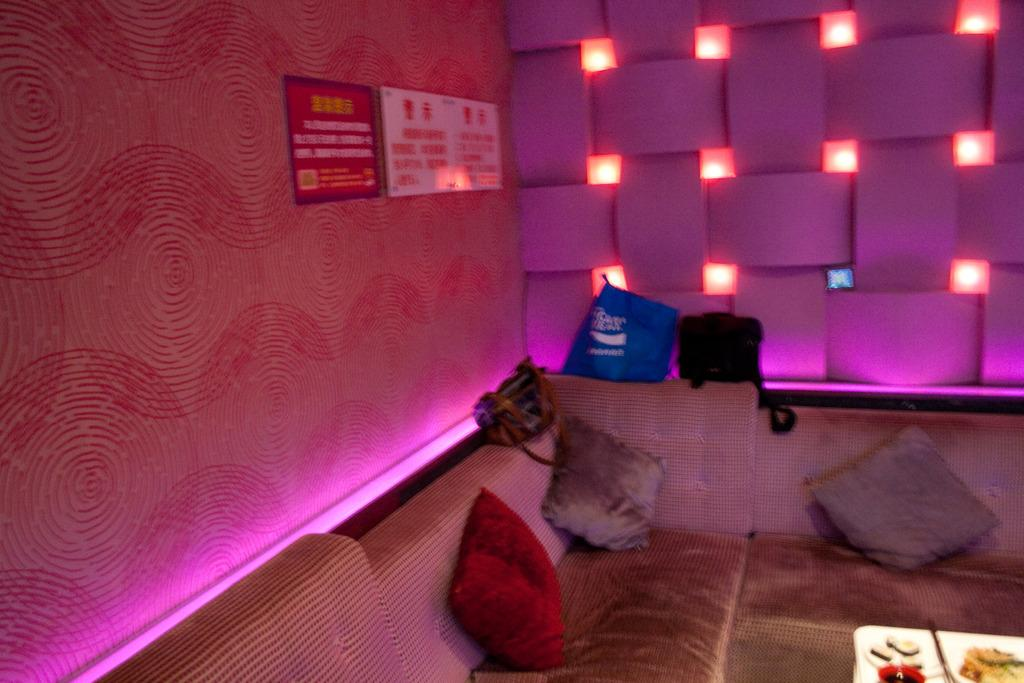What type of furniture is present in the image? There is a sofa in the image. What is placed on the sofa? There are bags on the sofa. What else can be seen in the image besides the sofa and bags? There is a board in the image. What is written on the board? Text is written on the board. Can you tell me what type of pan is being used by the doctor in the image? There is no pan or doctor present in the image. 